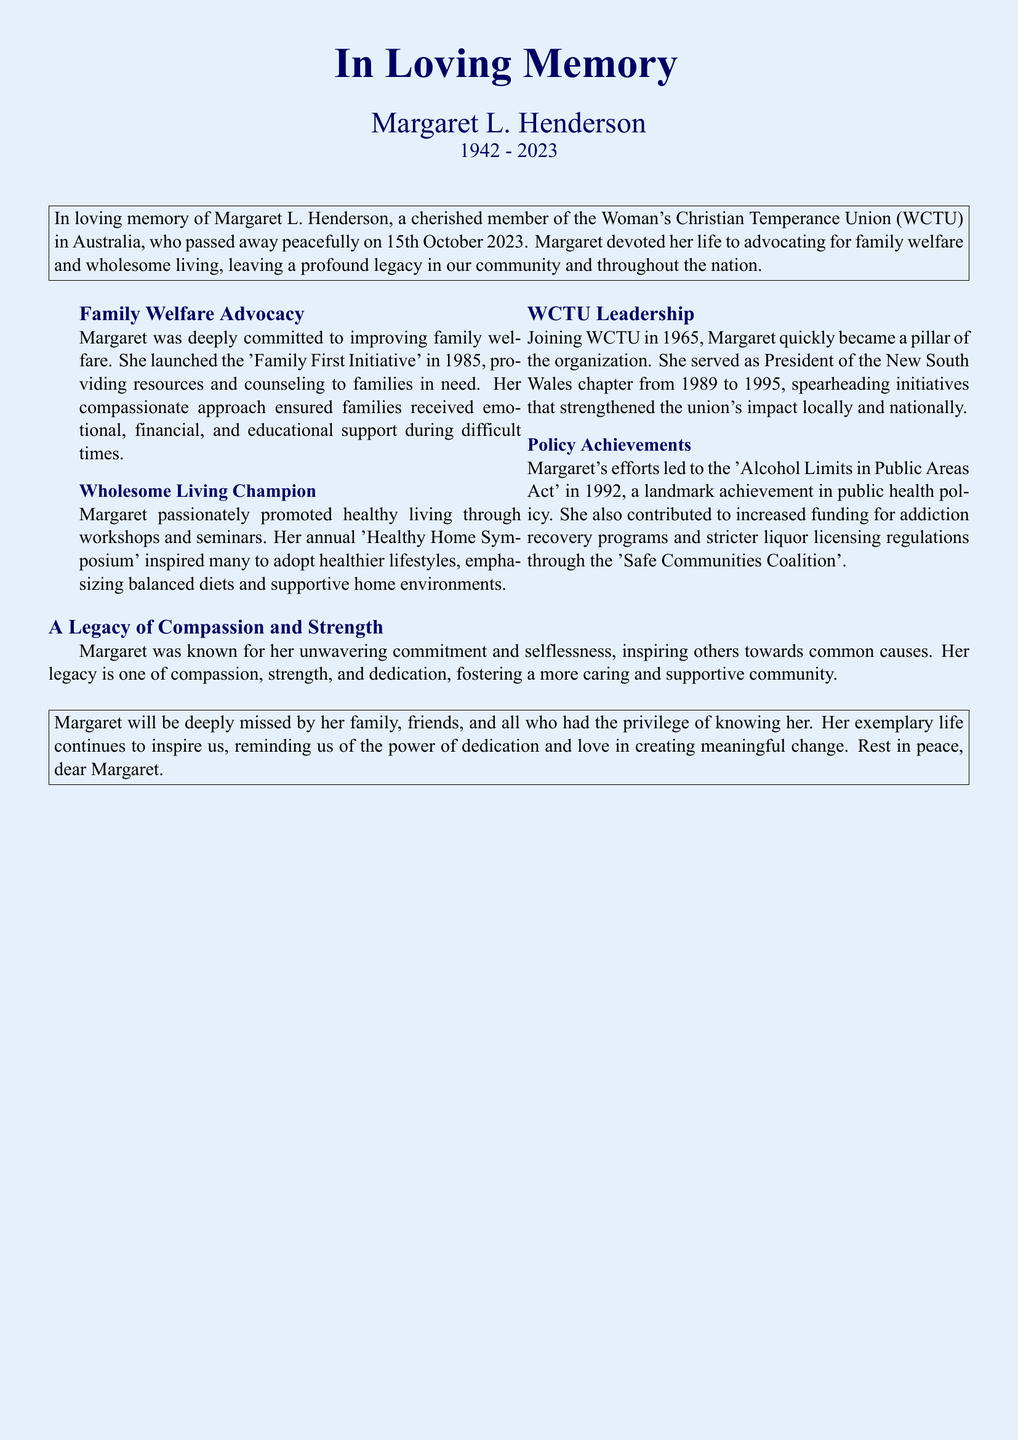What was Margaret's full name? The document states her full name as "Margaret L. Henderson."
Answer: Margaret L. Henderson What year did Margaret join the WCTU? The document mentions she joined the WCTU in 1965.
Answer: 1965 What initiative did Margaret launch in 1985? The document refers to the initiative as the "Family First Initiative."
Answer: Family First Initiative In what year was the 'Alcohol Limits in Public Areas Act' achieved? The document states this policy was established in 1992.
Answer: 1992 How long did Margaret serve as the President of the New South Wales chapter? The document specifies she served from 1989 to 1995, which is 6 years.
Answer: 6 years What did Margaret promote through workshops and seminars? The document notes she promoted "healthy living."
Answer: healthy living What title is given to the section discussing Margaret's impact on community welfare? The document has a section titled "A Legacy of Compassion and Strength."
Answer: A Legacy of Compassion and Strength Who will deeply miss Margaret according to the document? The document states that "her family, friends, and all who had the privilege of knowing her" will miss her.
Answer: her family, friends, and all who had the privilege of knowing her What type of legacy did Margaret leave behind? The document describes her legacy as one of "compassion, strength, and dedication."
Answer: compassion, strength, and dedication 